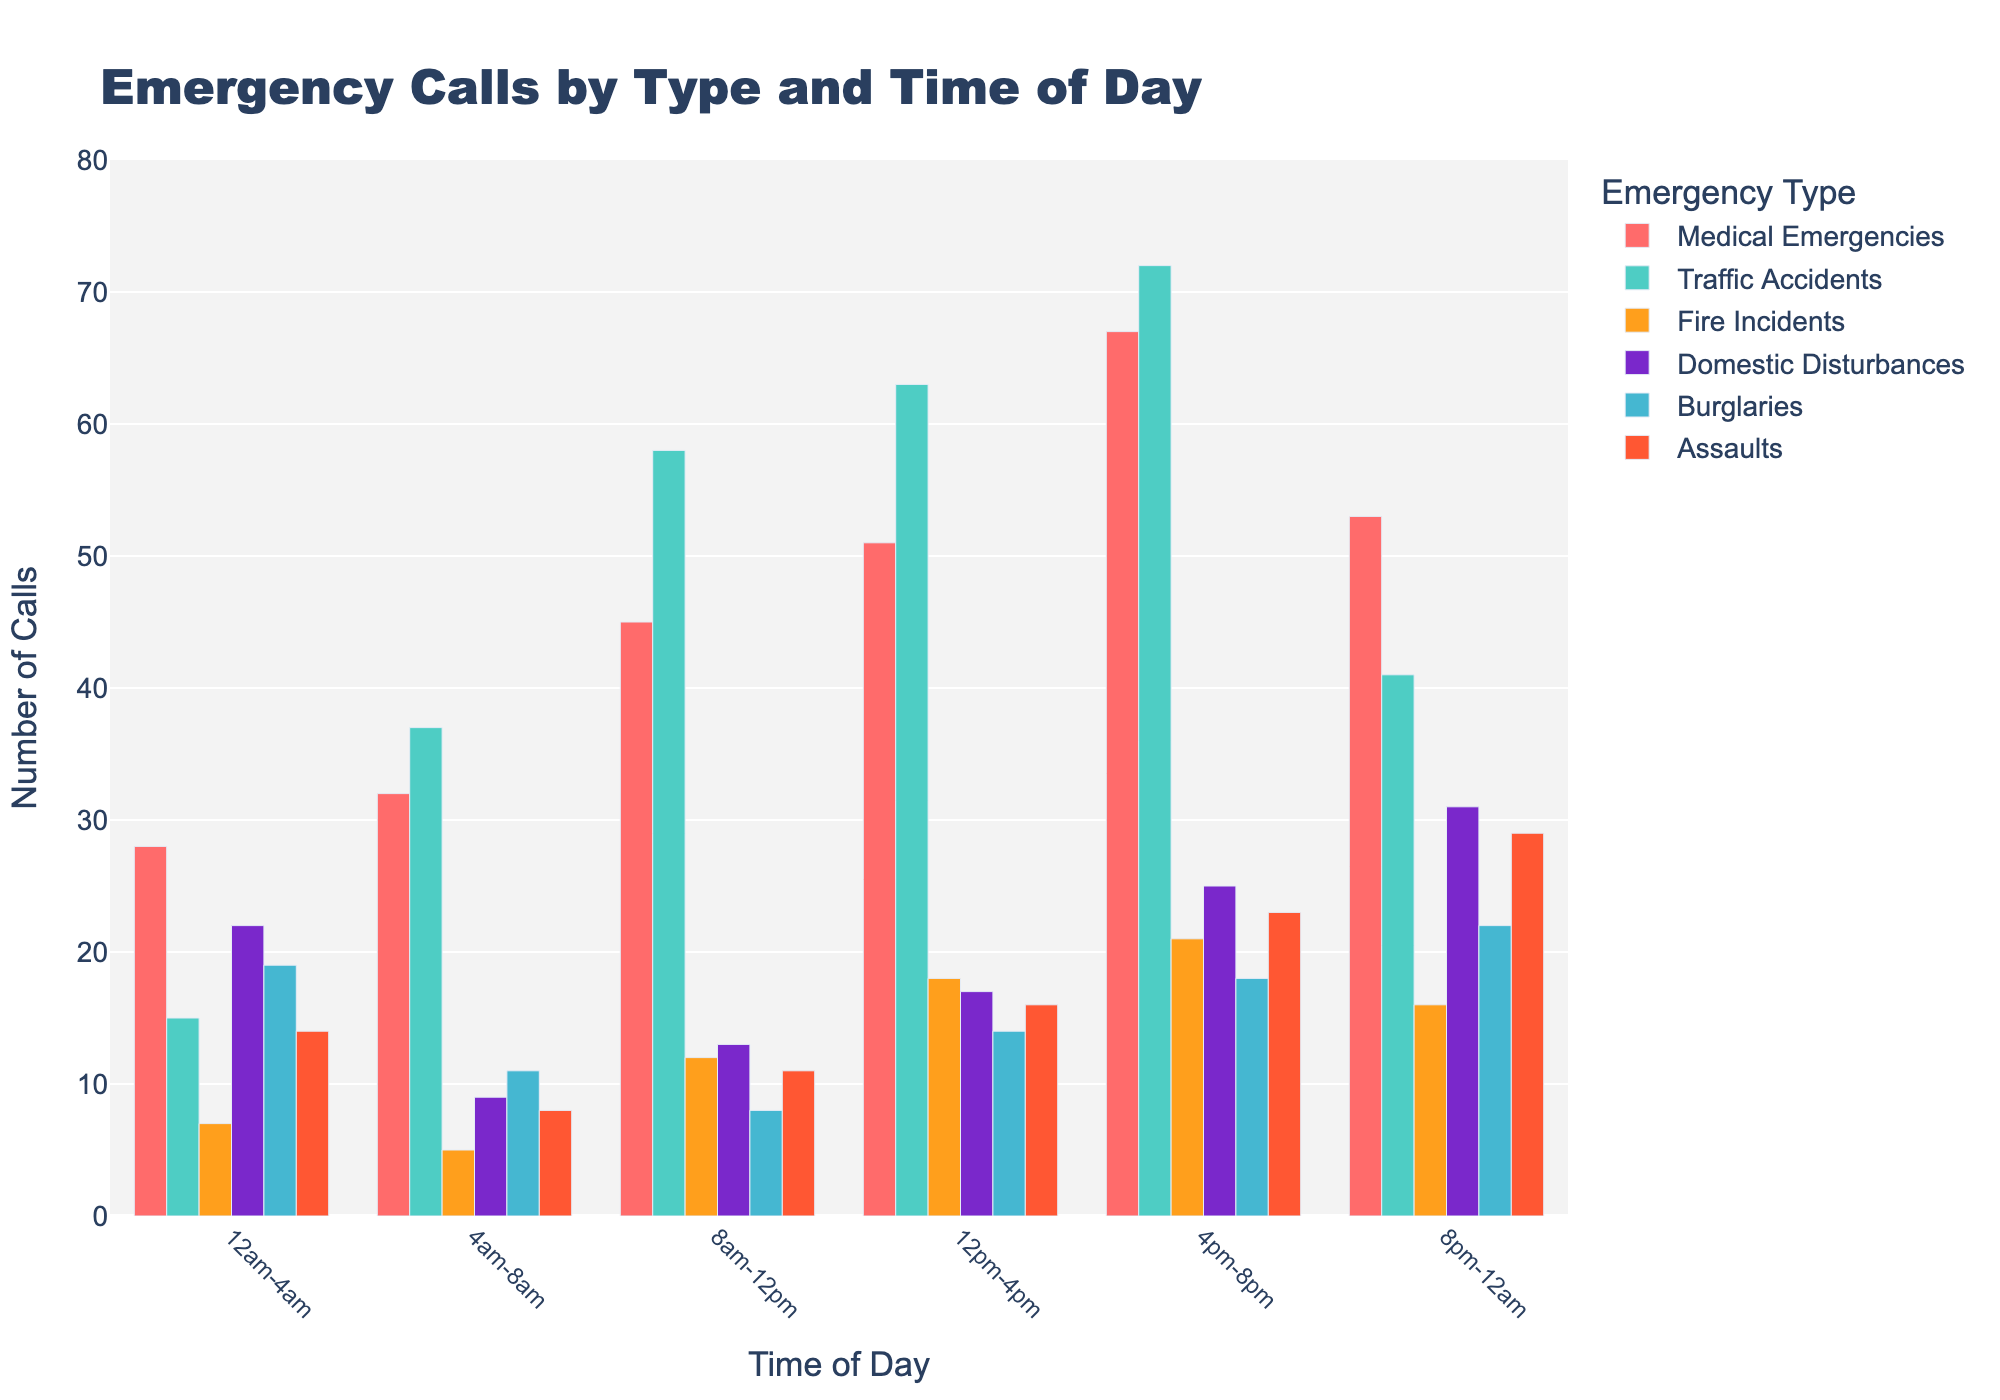What's the highest number of emergency calls received in a single type within any time period? Look at the bar chart for the highest bars and find the specific time and type. The highest number of emergency calls is 72 for Traffic Accidents during 4pm-8pm.
Answer: 72 What's the combined total of Medical Emergencies and Assaults during 4pm-8pm? Add the counts for Medical Emergencies (67) and Assaults (23) during 4pm-8pm. 67 + 23 = 90
Answer: 90 Which emergency type has the fewest calls during 12am-4am? Look at the lowest bar within the 12am-4am time slot. Fire Incidents have the fewest calls at 7.
Answer: Fire Incidents How many more Traffic Accidents were there during 8am-12pm compared to 4am-8am? Subtract the number of Traffic Accidents during 4am-8am (37) from those during 8am-12pm (58). 58 - 37 = 21
Answer: 21 Which time period had the highest number of Domestic Disturbance calls? Look for the highest bar for Domestic Disturbances. The 8pm-12am time period had the highest number with 31 calls.
Answer: 8pm-12am What's the average number of Fire Incidents across all time periods? Add up the number of Fire Incidents across all time periods (7 + 5 + 12 + 18 + 21 + 16) and divide by the number of time periods (6). (7 + 5 + 12 + 18 + 21 + 16) / 6 = 79 / 6 ≈ 13.17
Answer: 13.17 During which time period did Burglaries exceed Domestic Disturbances? Compare the bar heights for Burglaries and Domestic Disturbances for each time period. In the 4am-8am time period, Burglaries (11) exceeded Domestic Disturbances (9).
Answer: 4am-8am How many total calls were made for all emergency types during the 12pm-4pm period? Sum all the counts for the 12pm-4pm period (51 + 63 + 18 + 17 + 14 + 16). 51 + 63 + 18 + 17 + 14 + 16 = 179
Answer: 179 